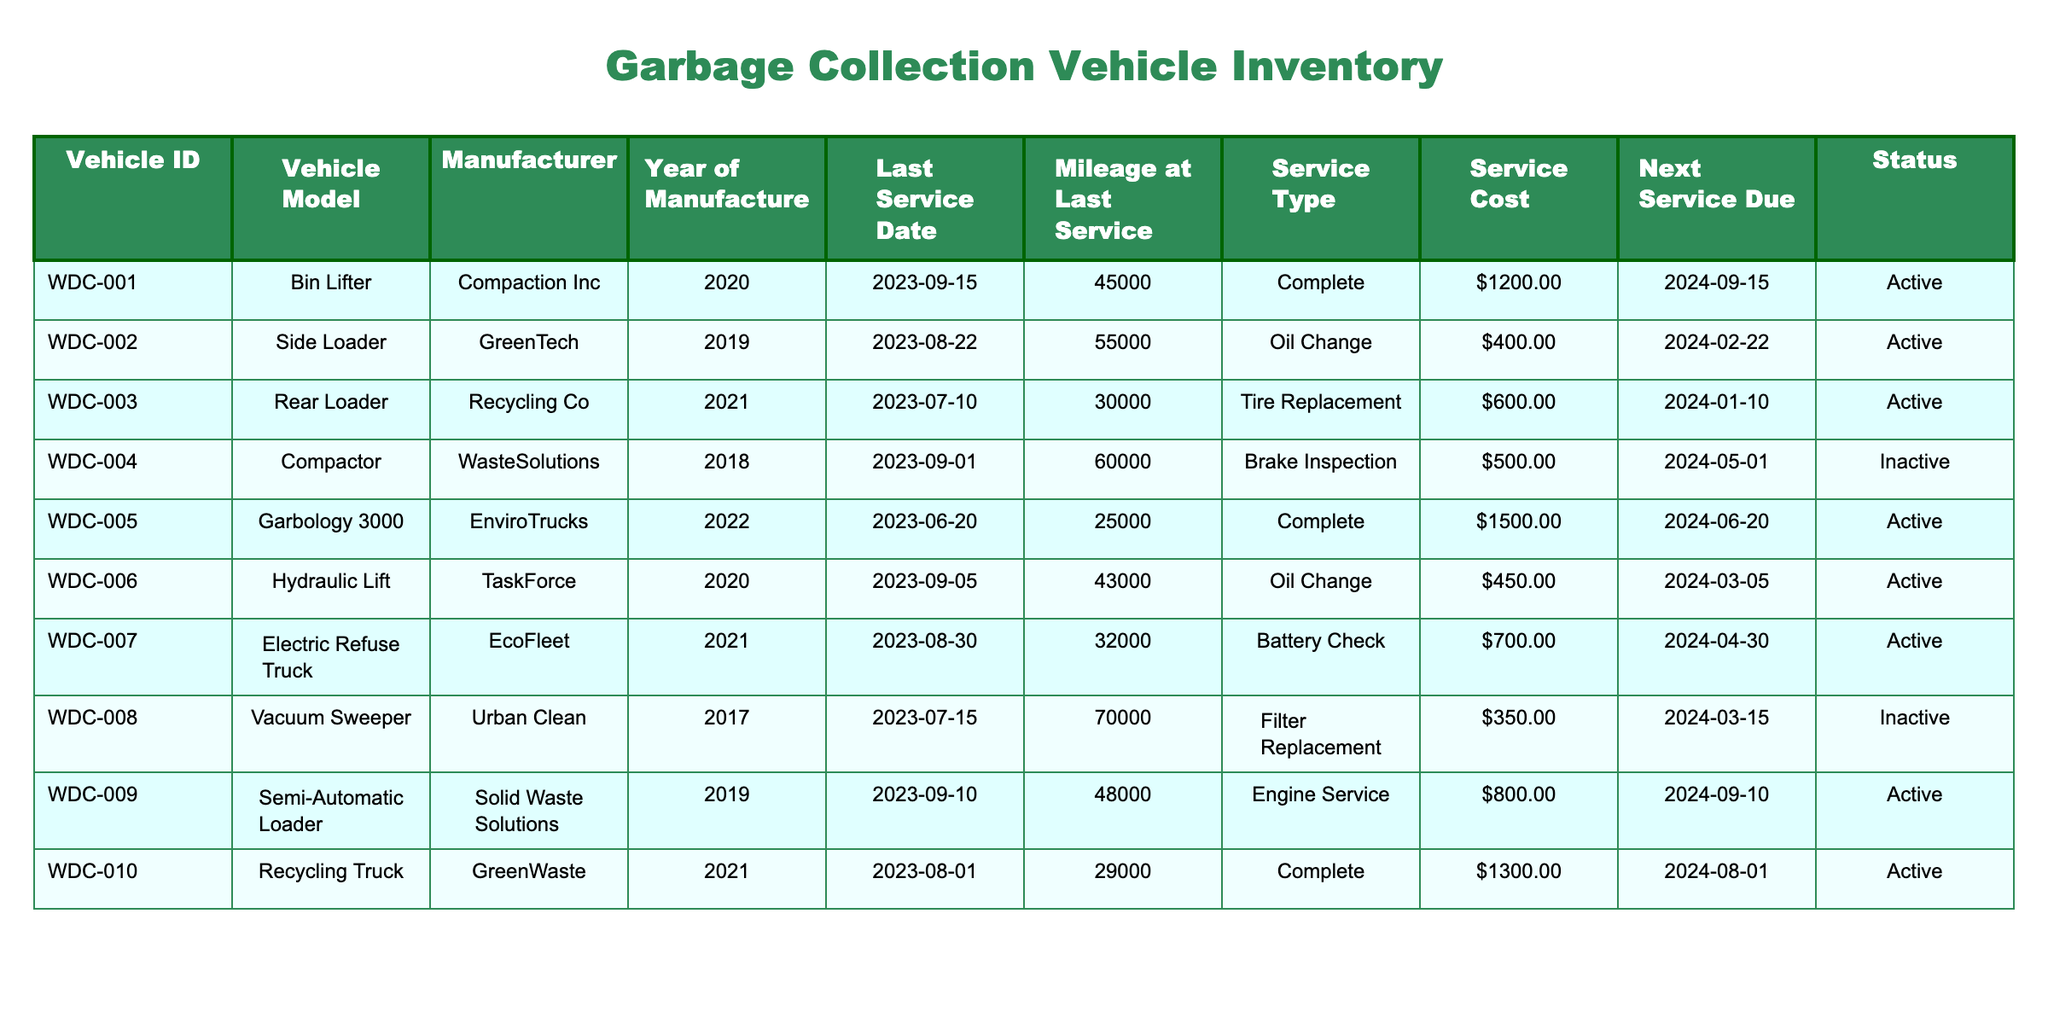What is the Vehicle ID of the Side Loader? The table lists the Vehicle ID under the "Vehicle ID" column. Looking for the row where the "Vehicle Model" is "Side Loader", I see that it corresponds to "WDC-002".
Answer: WDC-002 What service type was last performed on the Electric Refuse Truck? For the Electric Refuse Truck, which is identified in the "Vehicle Model" column, I locate the corresponding row and read the "Service Type" column, which states that the last service type was "Battery Check".
Answer: Battery Check How much did the last service cost for the Bin Lifter? Referring to the row for the Bin Lifter, I examine the "Service Cost" column which shows that the cost for the last service was $1200.00.
Answer: $1200.00 What is the average service cost for all active vehicles? To find the average service cost for active vehicles, I first identify active vehicles in the "Status" column. Their service costs are $1200.00, $400.00, $600.00, $1500.00, $450.00, $700.00, $800.00, and $1300.00. Adding these gives a total of $5100.00. There are 8 active vehicles, thus the average is 5100.00 / 8 = $637.50.
Answer: $637.50 Are all vehicles scheduled for their next service? I check the "Next Service Due" dates and compare them with the "Last Service Date." The next service due dates show that all vehicles have their next service scheduled based on their last service dates. Therefore, the answer is yes.
Answer: Yes How many vehicles have a service type of "Complete"? Looking through the "Service Type" column, I count the occurrences of "Complete". This appears for the Bin Lifter, Garbology 3000, and Recycling Truck, totaling 3 vehicles.
Answer: 3 Which vehicle has the highest mileage at the last service? I look at the "Mileage at Last Service" column and identify that the Vacuum Sweeper has the highest mileage at 70000. This is the maximum value in that column.
Answer: Vacuum Sweeper What is the status of the Compactor and when is it next service due? The row for the Compactor lists its status as "Inactive" in the "Status" column, and the next service due is noted as "2024-05-01" in the corresponding column.
Answer: Inactive, 2024-05-01 